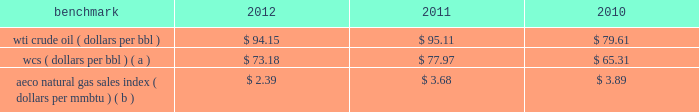Our international crude oil production is relatively sweet and is generally sold in relation to the brent crude benchmark .
The differential between wti and brent average prices widened significantly in 2011 and remained in 2012 in comparison to almost no differential in 2010 .
Natural gas 2013 a significant portion of our natural gas production in the lower 48 states of the u.s .
Is sold at bid-week prices or first-of-month indices relative to our specific producing areas .
Average henry hub settlement prices for natural gas were lower in 2012 than in recent years .
A decline in average settlement date henry hub natural gas prices began in september 2011 and continued into 2012 .
Although prices stabilized in late 2012 , they have not increased appreciably .
Our other major natural gas-producing regions are e.g .
And europe .
In the case of e.g .
Our natural gas sales are subject to term contracts , making realizations less volatile .
Because natural gas sales from e.g .
Are at fixed prices , our worldwide reported average natural gas realizations may not fully track market price movements .
Natural gas prices in europe have been significantly higher than in the u.s .
Oil sands mining the osm segment produces and sells various qualities of synthetic crude oil .
Output mix can be impacted by operational problems or planned unit outages at the mines or upgrader .
Sales prices for roughly two-thirds of the normal output mix will track movements in wti and one-third will track movements in the canadian heavy sour crude oil marker , primarily wcs .
In 2012 , the wcs discount from wti had increased , putting downward pressure on our average realizations .
The operating cost structure of the osm operations is predominantly fixed and therefore many of the costs incurred in times of full operation continue during production downtime .
Per-unit costs are sensitive to production rates .
Key variable costs are natural gas and diesel fuel , which track commodity markets such as the canadian alberta energy company ( "aeco" ) natural gas sales index and crude oil prices , respectively .
The table below shows average benchmark prices that impact both our revenues and variable costs. .
Wcs ( dollars per bbl ) ( a ) $ 73.18 $ 77.97 $ 65.31 aeco natural gas sales index ( dollars per mmbtu ) ( b ) $ 2.39 $ 3.68 $ 3.89 ( a ) monthly pricing based upon average wti adjusted for differentials unique to western canada .
( b ) monthly average day ahead index .
Integrated gas our ig operations include production and marketing of products manufactured from natural gas , such as lng and methanol , in e.g .
World lng trade in 2012 has been estimated to be 240 mmt .
Long-term , lng continues to be in demand as markets seek the benefits of clean burning natural gas .
Market prices for lng are not reported or posted .
In general , lng delivered to the u.s .
Is tied to henry hub prices and will track with changes in u.s .
Natural gas prices , while lng sold in europe and asia is indexed to crude oil prices and will track the movement of those prices .
We have a 60 percent ownership in an lng production facility in e.g. , which sells lng under a long-term contract at prices tied to henry hub natural gas prices .
Gross sales from the plant were 3.8 mmt , 4.1 mmt and 3.7 mmt in 2012 , 2011 and 2010 .
We own a 45 percent interest in a methanol plant located in e.g .
Through our investment in ampco .
Gross sales of methanol from the plant totaled 1.1 mmt , 1.0 mmt and 0.9 mmt in 2012 , 2011 and 2010 .
Methanol demand has a direct impact on ampco 2019s earnings .
Because global demand for methanol is rather limited , changes in the supply-demand balance can have a significant impact on sales prices .
World demand for methanol in 2012 has been estimated to be 49 mmt .
Our plant capacity of 1.1 mmt is about 2 percent of world demand. .
What was the difference in the average price of wti crude and wcs in 2012? 
Computations: (94.15 - 73.18)
Answer: 20.97. 